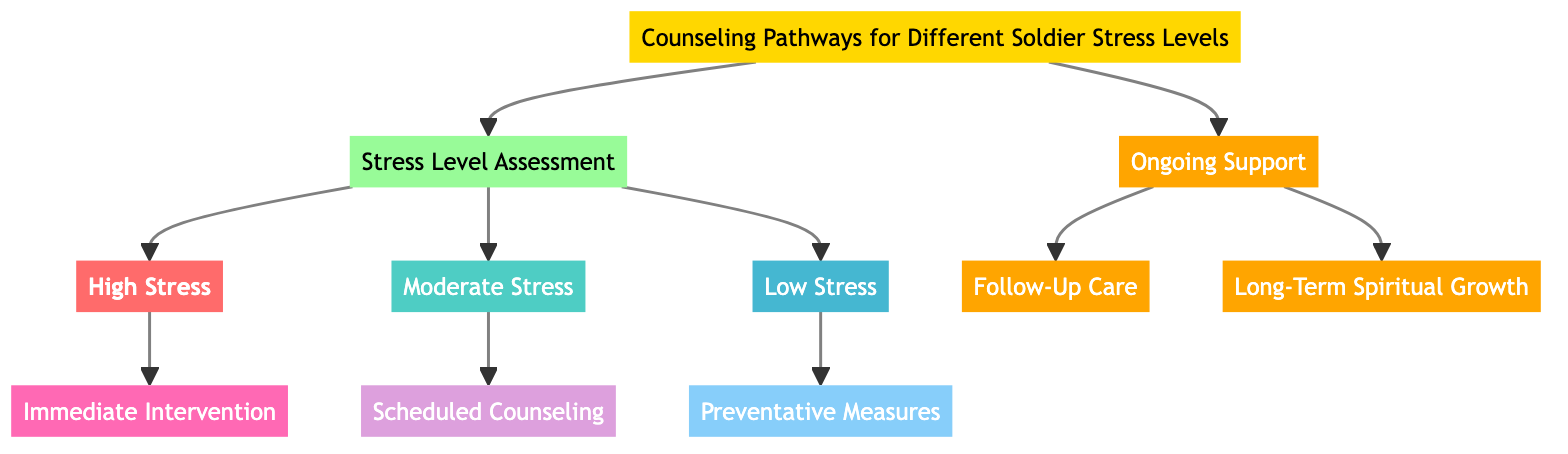What is the first step for a soldier with high stress? The diagram shows that the first step for a soldier assessed with high stress is to ensure immediate safety and stabilize the soldier. This is detailed under the "Immediate Intervention" node connected to "High Stress".
Answer: Ensure immediate safety and stabilize the soldier How many stress levels are identified in the diagram? By examining the "Stress Level Assessment" node, we see three distinct branches for stress levels: High Stress, Moderate Stress, and Low Stress. Therefore, there are three stress levels identified.
Answer: 3 What type of care is recommended for moderate stress? Looking at the "Moderate Stress" node, it indicates that the recommended care is "Scheduled Counseling", which is directly connected to the moderate stress assessment.
Answer: Scheduled Counseling What are the steps included in Follow-Up Care? The "Follow-Up Care" node lists three steps: regular check-ins with soldiers, modify counseling plans as needed, and coordinate with medical staff. These steps are all related to ongoing care after initial intervention.
Answer: Regular check-ins with soldiers, modify counseling plans as needed, coordinate with medical staff How is "Preventative Measures" connected in the diagram? The "Preventative Measures" node is connected under the "Low Stress" assessment branch, indicating that it is the recommended approach for soldiers who show low stress levels. This connection highlights how different stress levels lead to different types of interventions.
Answer: Under Low Stress What is the criteria for long-term spiritual growth? The "Long-Term Spiritual Growth" node specifically mentions fostering resilience and growth over time as its criteria. This requirement emphasizes the goals of the spiritual support over a prolonged period.
Answer: Fostering resilience and growth over time Which path involves emergency pastoral care? The path involving emergency pastoral care is listed under the "Immediate Intervention" steps corresponding to soldiers with high stress. It indicates that spiritual support is crucial in crisis situations.
Answer: Immediate Intervention How many steps are there under Scheduled Counseling? Within the "Scheduled Counseling" node, we see three distinct steps which detail the actions to be taken. This corresponds to the structured approach for managing moderate stress levels.
Answer: 3 